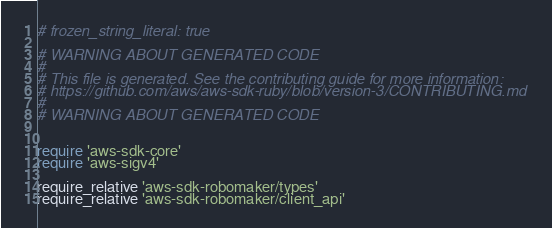Convert code to text. <code><loc_0><loc_0><loc_500><loc_500><_Ruby_># frozen_string_literal: true

# WARNING ABOUT GENERATED CODE
#
# This file is generated. See the contributing guide for more information:
# https://github.com/aws/aws-sdk-ruby/blob/version-3/CONTRIBUTING.md
#
# WARNING ABOUT GENERATED CODE


require 'aws-sdk-core'
require 'aws-sigv4'

require_relative 'aws-sdk-robomaker/types'
require_relative 'aws-sdk-robomaker/client_api'</code> 